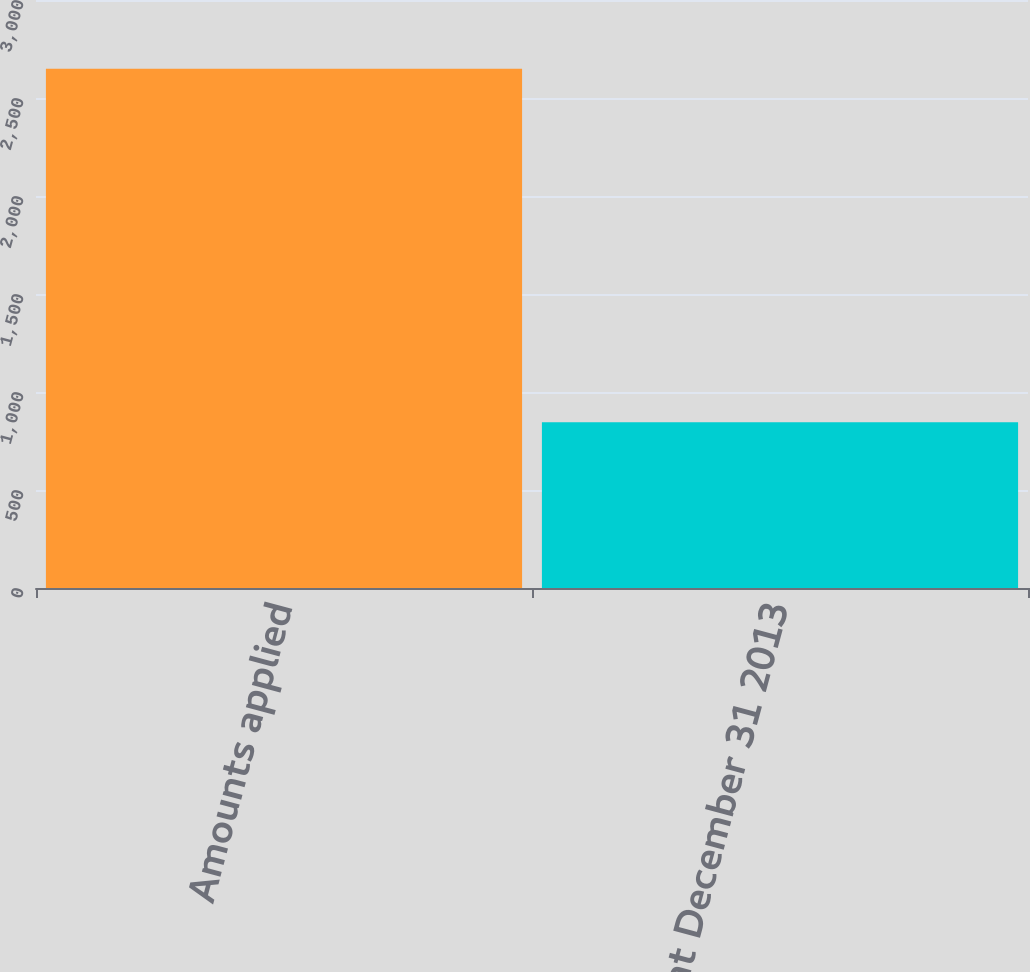<chart> <loc_0><loc_0><loc_500><loc_500><bar_chart><fcel>Amounts applied<fcel>Balance at December 31 2013<nl><fcel>2649<fcel>846<nl></chart> 